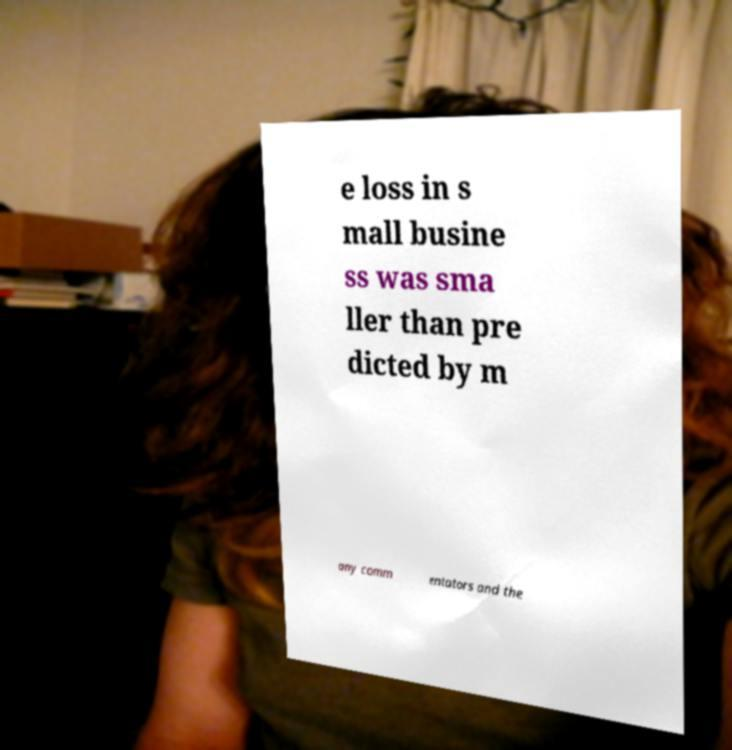For documentation purposes, I need the text within this image transcribed. Could you provide that? e loss in s mall busine ss was sma ller than pre dicted by m any comm entators and the 